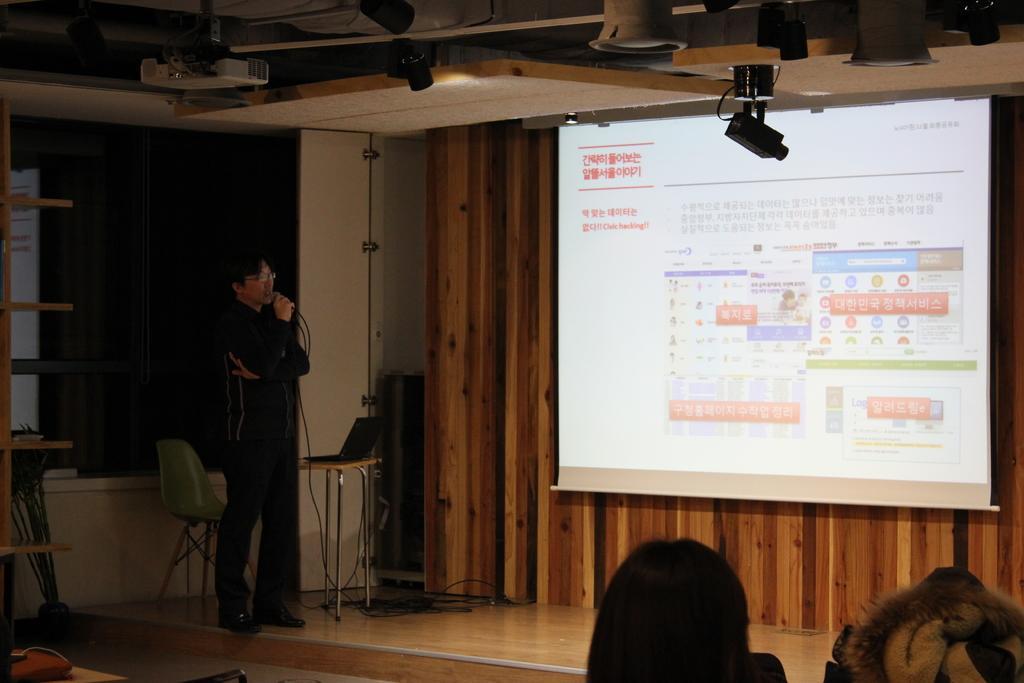How would you summarize this image in a sentence or two? In this image there is a man standing on the stage by holding the mic. On the right side there is a screen. At the top there are lights and a projector. At the bottom there are few people. Beside the man there is a chair and a laptop on the table. 